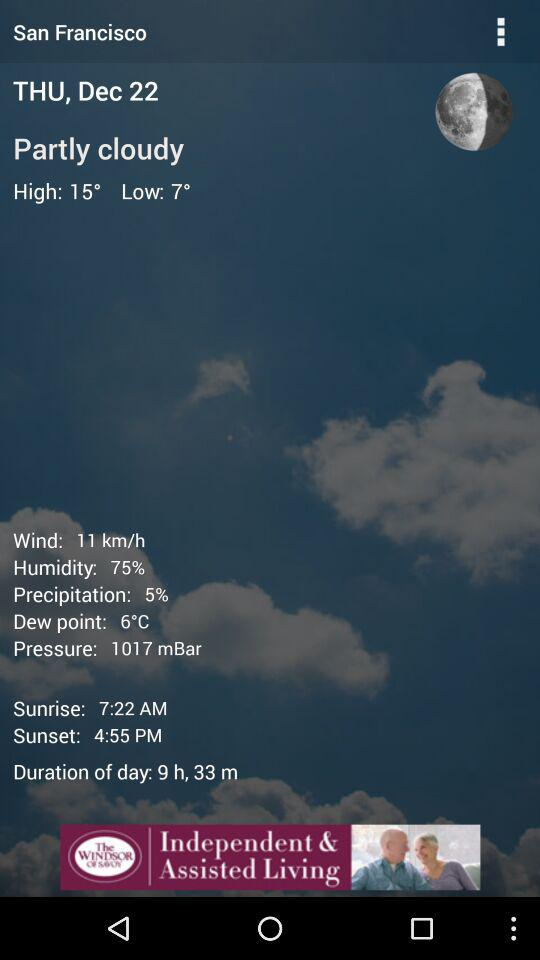What is the date? The date is Thursday, December 22. 